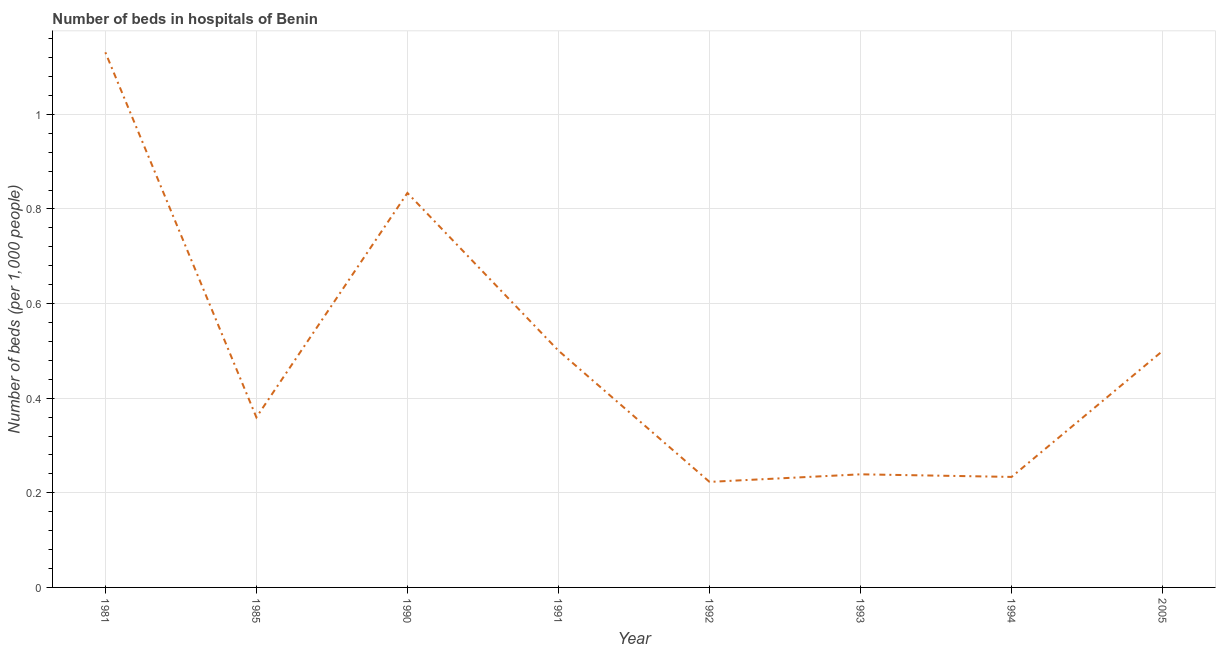What is the number of hospital beds in 1994?
Offer a terse response. 0.23. Across all years, what is the maximum number of hospital beds?
Offer a terse response. 1.13. Across all years, what is the minimum number of hospital beds?
Give a very brief answer. 0.22. What is the sum of the number of hospital beds?
Your answer should be very brief. 4.02. What is the difference between the number of hospital beds in 1993 and 1994?
Provide a short and direct response. 0.01. What is the average number of hospital beds per year?
Your response must be concise. 0.5. What is the median number of hospital beds?
Your answer should be compact. 0.43. In how many years, is the number of hospital beds greater than 0.28 %?
Ensure brevity in your answer.  5. Do a majority of the years between 1981 and 2005 (inclusive) have number of hospital beds greater than 0.12 %?
Your answer should be very brief. Yes. What is the ratio of the number of hospital beds in 1985 to that in 2005?
Give a very brief answer. 0.72. Is the difference between the number of hospital beds in 1992 and 2005 greater than the difference between any two years?
Offer a terse response. No. What is the difference between the highest and the second highest number of hospital beds?
Give a very brief answer. 0.3. What is the difference between the highest and the lowest number of hospital beds?
Your response must be concise. 0.91. In how many years, is the number of hospital beds greater than the average number of hospital beds taken over all years?
Offer a terse response. 2. Does the number of hospital beds monotonically increase over the years?
Give a very brief answer. No. What is the difference between two consecutive major ticks on the Y-axis?
Provide a short and direct response. 0.2. Does the graph contain any zero values?
Offer a terse response. No. What is the title of the graph?
Provide a short and direct response. Number of beds in hospitals of Benin. What is the label or title of the Y-axis?
Your answer should be very brief. Number of beds (per 1,0 people). What is the Number of beds (per 1,000 people) of 1981?
Your answer should be compact. 1.13. What is the Number of beds (per 1,000 people) in 1985?
Your answer should be very brief. 0.36. What is the Number of beds (per 1,000 people) in 1990?
Offer a terse response. 0.83. What is the Number of beds (per 1,000 people) in 1991?
Provide a succinct answer. 0.5. What is the Number of beds (per 1,000 people) in 1992?
Provide a succinct answer. 0.22. What is the Number of beds (per 1,000 people) of 1993?
Offer a very short reply. 0.24. What is the Number of beds (per 1,000 people) of 1994?
Your response must be concise. 0.23. What is the Number of beds (per 1,000 people) in 2005?
Make the answer very short. 0.5. What is the difference between the Number of beds (per 1,000 people) in 1981 and 1985?
Your response must be concise. 0.77. What is the difference between the Number of beds (per 1,000 people) in 1981 and 1990?
Your response must be concise. 0.3. What is the difference between the Number of beds (per 1,000 people) in 1981 and 1991?
Offer a very short reply. 0.63. What is the difference between the Number of beds (per 1,000 people) in 1981 and 1992?
Make the answer very short. 0.91. What is the difference between the Number of beds (per 1,000 people) in 1981 and 1993?
Ensure brevity in your answer.  0.89. What is the difference between the Number of beds (per 1,000 people) in 1981 and 1994?
Provide a succinct answer. 0.9. What is the difference between the Number of beds (per 1,000 people) in 1981 and 2005?
Provide a succinct answer. 0.63. What is the difference between the Number of beds (per 1,000 people) in 1985 and 1990?
Keep it short and to the point. -0.47. What is the difference between the Number of beds (per 1,000 people) in 1985 and 1991?
Offer a terse response. -0.14. What is the difference between the Number of beds (per 1,000 people) in 1985 and 1992?
Offer a terse response. 0.14. What is the difference between the Number of beds (per 1,000 people) in 1985 and 1993?
Make the answer very short. 0.12. What is the difference between the Number of beds (per 1,000 people) in 1985 and 1994?
Give a very brief answer. 0.13. What is the difference between the Number of beds (per 1,000 people) in 1985 and 2005?
Ensure brevity in your answer.  -0.14. What is the difference between the Number of beds (per 1,000 people) in 1990 and 1991?
Provide a short and direct response. 0.33. What is the difference between the Number of beds (per 1,000 people) in 1990 and 1992?
Offer a very short reply. 0.61. What is the difference between the Number of beds (per 1,000 people) in 1990 and 1993?
Offer a very short reply. 0.59. What is the difference between the Number of beds (per 1,000 people) in 1990 and 1994?
Provide a succinct answer. 0.6. What is the difference between the Number of beds (per 1,000 people) in 1990 and 2005?
Provide a succinct answer. 0.33. What is the difference between the Number of beds (per 1,000 people) in 1991 and 1992?
Keep it short and to the point. 0.28. What is the difference between the Number of beds (per 1,000 people) in 1991 and 1993?
Provide a succinct answer. 0.26. What is the difference between the Number of beds (per 1,000 people) in 1991 and 1994?
Provide a short and direct response. 0.27. What is the difference between the Number of beds (per 1,000 people) in 1992 and 1993?
Make the answer very short. -0.02. What is the difference between the Number of beds (per 1,000 people) in 1992 and 1994?
Your response must be concise. -0.01. What is the difference between the Number of beds (per 1,000 people) in 1992 and 2005?
Offer a terse response. -0.28. What is the difference between the Number of beds (per 1,000 people) in 1993 and 1994?
Give a very brief answer. 0.01. What is the difference between the Number of beds (per 1,000 people) in 1993 and 2005?
Your response must be concise. -0.26. What is the difference between the Number of beds (per 1,000 people) in 1994 and 2005?
Ensure brevity in your answer.  -0.27. What is the ratio of the Number of beds (per 1,000 people) in 1981 to that in 1985?
Provide a short and direct response. 3.15. What is the ratio of the Number of beds (per 1,000 people) in 1981 to that in 1990?
Provide a succinct answer. 1.36. What is the ratio of the Number of beds (per 1,000 people) in 1981 to that in 1991?
Your response must be concise. 2.26. What is the ratio of the Number of beds (per 1,000 people) in 1981 to that in 1992?
Make the answer very short. 5.07. What is the ratio of the Number of beds (per 1,000 people) in 1981 to that in 1993?
Offer a terse response. 4.73. What is the ratio of the Number of beds (per 1,000 people) in 1981 to that in 1994?
Provide a succinct answer. 4.84. What is the ratio of the Number of beds (per 1,000 people) in 1981 to that in 2005?
Give a very brief answer. 2.26. What is the ratio of the Number of beds (per 1,000 people) in 1985 to that in 1990?
Your response must be concise. 0.43. What is the ratio of the Number of beds (per 1,000 people) in 1985 to that in 1991?
Make the answer very short. 0.72. What is the ratio of the Number of beds (per 1,000 people) in 1985 to that in 1992?
Give a very brief answer. 1.61. What is the ratio of the Number of beds (per 1,000 people) in 1985 to that in 1993?
Make the answer very short. 1.5. What is the ratio of the Number of beds (per 1,000 people) in 1985 to that in 1994?
Give a very brief answer. 1.54. What is the ratio of the Number of beds (per 1,000 people) in 1985 to that in 2005?
Offer a terse response. 0.72. What is the ratio of the Number of beds (per 1,000 people) in 1990 to that in 1991?
Your answer should be very brief. 1.67. What is the ratio of the Number of beds (per 1,000 people) in 1990 to that in 1992?
Offer a very short reply. 3.74. What is the ratio of the Number of beds (per 1,000 people) in 1990 to that in 1993?
Provide a succinct answer. 3.49. What is the ratio of the Number of beds (per 1,000 people) in 1990 to that in 1994?
Provide a succinct answer. 3.57. What is the ratio of the Number of beds (per 1,000 people) in 1990 to that in 2005?
Keep it short and to the point. 1.67. What is the ratio of the Number of beds (per 1,000 people) in 1991 to that in 1992?
Provide a short and direct response. 2.24. What is the ratio of the Number of beds (per 1,000 people) in 1991 to that in 1993?
Provide a succinct answer. 2.09. What is the ratio of the Number of beds (per 1,000 people) in 1991 to that in 1994?
Make the answer very short. 2.14. What is the ratio of the Number of beds (per 1,000 people) in 1991 to that in 2005?
Offer a terse response. 1. What is the ratio of the Number of beds (per 1,000 people) in 1992 to that in 1993?
Give a very brief answer. 0.93. What is the ratio of the Number of beds (per 1,000 people) in 1992 to that in 1994?
Make the answer very short. 0.95. What is the ratio of the Number of beds (per 1,000 people) in 1992 to that in 2005?
Your response must be concise. 0.45. What is the ratio of the Number of beds (per 1,000 people) in 1993 to that in 2005?
Your response must be concise. 0.48. What is the ratio of the Number of beds (per 1,000 people) in 1994 to that in 2005?
Keep it short and to the point. 0.47. 